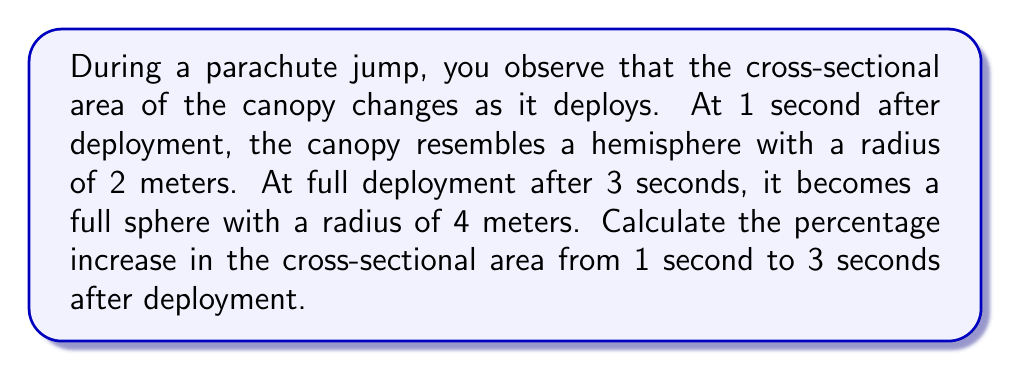Give your solution to this math problem. Let's approach this step-by-step:

1) At 1 second (hemisphere):
   - Radius $r_1 = 2$ meters
   - Cross-sectional area of a hemisphere: $A_1 = \pi r_1^2$
   - $A_1 = \pi (2)^2 = 4\pi$ sq meters

2) At 3 seconds (full sphere):
   - Radius $r_2 = 4$ meters
   - Cross-sectional area of a sphere: $A_2 = \pi r_2^2$
   - $A_2 = \pi (4)^2 = 16\pi$ sq meters

3) Calculate the increase in area:
   $\Delta A = A_2 - A_1 = 16\pi - 4\pi = 12\pi$ sq meters

4) Calculate the percentage increase:
   $$\text{Percentage increase} = \frac{\Delta A}{A_1} \times 100\% = \frac{12\pi}{4\pi} \times 100\% = 3 \times 100\% = 300\%$$

Therefore, the cross-sectional area increases by 300% from 1 second to 3 seconds after deployment.
Answer: 300% 